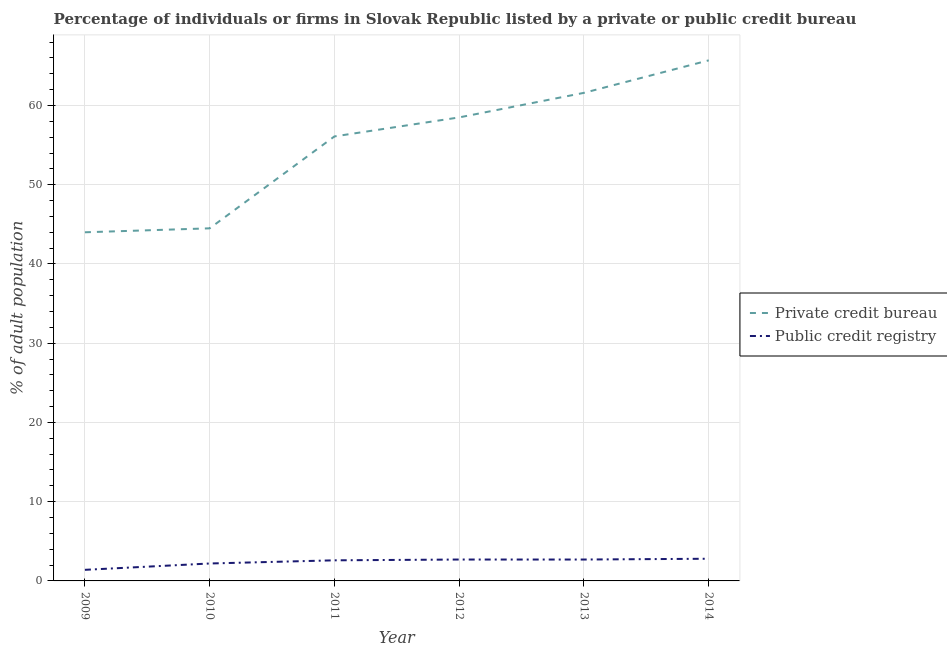How many different coloured lines are there?
Offer a terse response. 2. Is the number of lines equal to the number of legend labels?
Your answer should be compact. Yes. What is the percentage of firms listed by private credit bureau in 2014?
Your answer should be compact. 65.7. Across all years, what is the maximum percentage of firms listed by private credit bureau?
Offer a very short reply. 65.7. Across all years, what is the minimum percentage of firms listed by private credit bureau?
Make the answer very short. 44. In which year was the percentage of firms listed by public credit bureau maximum?
Offer a terse response. 2014. What is the total percentage of firms listed by private credit bureau in the graph?
Offer a very short reply. 330.4. What is the difference between the percentage of firms listed by private credit bureau in 2012 and that in 2013?
Offer a terse response. -3.1. What is the difference between the percentage of firms listed by public credit bureau in 2011 and the percentage of firms listed by private credit bureau in 2014?
Offer a very short reply. -63.1. What is the average percentage of firms listed by public credit bureau per year?
Provide a succinct answer. 2.4. In the year 2014, what is the difference between the percentage of firms listed by public credit bureau and percentage of firms listed by private credit bureau?
Provide a short and direct response. -62.9. What is the ratio of the percentage of firms listed by private credit bureau in 2011 to that in 2014?
Your answer should be very brief. 0.85. What is the difference between the highest and the second highest percentage of firms listed by private credit bureau?
Ensure brevity in your answer.  4.1. What is the difference between the highest and the lowest percentage of firms listed by private credit bureau?
Your response must be concise. 21.7. Is the sum of the percentage of firms listed by private credit bureau in 2011 and 2012 greater than the maximum percentage of firms listed by public credit bureau across all years?
Offer a very short reply. Yes. Is the percentage of firms listed by private credit bureau strictly greater than the percentage of firms listed by public credit bureau over the years?
Make the answer very short. Yes. How many years are there in the graph?
Make the answer very short. 6. What is the difference between two consecutive major ticks on the Y-axis?
Ensure brevity in your answer.  10. Are the values on the major ticks of Y-axis written in scientific E-notation?
Your answer should be very brief. No. Does the graph contain grids?
Offer a terse response. Yes. What is the title of the graph?
Offer a very short reply. Percentage of individuals or firms in Slovak Republic listed by a private or public credit bureau. Does "Automatic Teller Machines" appear as one of the legend labels in the graph?
Ensure brevity in your answer.  No. What is the label or title of the X-axis?
Provide a succinct answer. Year. What is the label or title of the Y-axis?
Provide a short and direct response. % of adult population. What is the % of adult population of Public credit registry in 2009?
Your answer should be very brief. 1.4. What is the % of adult population in Private credit bureau in 2010?
Your response must be concise. 44.5. What is the % of adult population of Private credit bureau in 2011?
Make the answer very short. 56.1. What is the % of adult population of Private credit bureau in 2012?
Your response must be concise. 58.5. What is the % of adult population in Private credit bureau in 2013?
Provide a succinct answer. 61.6. What is the % of adult population of Public credit registry in 2013?
Provide a short and direct response. 2.7. What is the % of adult population in Private credit bureau in 2014?
Make the answer very short. 65.7. Across all years, what is the maximum % of adult population of Private credit bureau?
Offer a terse response. 65.7. Across all years, what is the maximum % of adult population in Public credit registry?
Your answer should be compact. 2.8. What is the total % of adult population of Private credit bureau in the graph?
Your answer should be compact. 330.4. What is the total % of adult population in Public credit registry in the graph?
Make the answer very short. 14.4. What is the difference between the % of adult population in Private credit bureau in 2009 and that in 2010?
Your answer should be compact. -0.5. What is the difference between the % of adult population in Public credit registry in 2009 and that in 2010?
Provide a short and direct response. -0.8. What is the difference between the % of adult population of Private credit bureau in 2009 and that in 2011?
Make the answer very short. -12.1. What is the difference between the % of adult population of Private credit bureau in 2009 and that in 2012?
Make the answer very short. -14.5. What is the difference between the % of adult population in Private credit bureau in 2009 and that in 2013?
Your response must be concise. -17.6. What is the difference between the % of adult population of Private credit bureau in 2009 and that in 2014?
Give a very brief answer. -21.7. What is the difference between the % of adult population of Public credit registry in 2009 and that in 2014?
Your answer should be very brief. -1.4. What is the difference between the % of adult population of Private credit bureau in 2010 and that in 2011?
Your response must be concise. -11.6. What is the difference between the % of adult population in Private credit bureau in 2010 and that in 2012?
Your response must be concise. -14. What is the difference between the % of adult population in Public credit registry in 2010 and that in 2012?
Keep it short and to the point. -0.5. What is the difference between the % of adult population in Private credit bureau in 2010 and that in 2013?
Provide a succinct answer. -17.1. What is the difference between the % of adult population in Public credit registry in 2010 and that in 2013?
Provide a short and direct response. -0.5. What is the difference between the % of adult population of Private credit bureau in 2010 and that in 2014?
Offer a very short reply. -21.2. What is the difference between the % of adult population in Public credit registry in 2011 and that in 2012?
Provide a succinct answer. -0.1. What is the difference between the % of adult population of Private credit bureau in 2012 and that in 2013?
Provide a succinct answer. -3.1. What is the difference between the % of adult population in Public credit registry in 2012 and that in 2013?
Provide a short and direct response. 0. What is the difference between the % of adult population in Private credit bureau in 2012 and that in 2014?
Offer a terse response. -7.2. What is the difference between the % of adult population in Public credit registry in 2012 and that in 2014?
Offer a terse response. -0.1. What is the difference between the % of adult population of Private credit bureau in 2009 and the % of adult population of Public credit registry in 2010?
Provide a succinct answer. 41.8. What is the difference between the % of adult population of Private credit bureau in 2009 and the % of adult population of Public credit registry in 2011?
Give a very brief answer. 41.4. What is the difference between the % of adult population of Private credit bureau in 2009 and the % of adult population of Public credit registry in 2012?
Offer a terse response. 41.3. What is the difference between the % of adult population in Private credit bureau in 2009 and the % of adult population in Public credit registry in 2013?
Provide a short and direct response. 41.3. What is the difference between the % of adult population of Private credit bureau in 2009 and the % of adult population of Public credit registry in 2014?
Provide a short and direct response. 41.2. What is the difference between the % of adult population of Private credit bureau in 2010 and the % of adult population of Public credit registry in 2011?
Offer a terse response. 41.9. What is the difference between the % of adult population of Private credit bureau in 2010 and the % of adult population of Public credit registry in 2012?
Make the answer very short. 41.8. What is the difference between the % of adult population in Private credit bureau in 2010 and the % of adult population in Public credit registry in 2013?
Make the answer very short. 41.8. What is the difference between the % of adult population of Private credit bureau in 2010 and the % of adult population of Public credit registry in 2014?
Your answer should be very brief. 41.7. What is the difference between the % of adult population of Private credit bureau in 2011 and the % of adult population of Public credit registry in 2012?
Keep it short and to the point. 53.4. What is the difference between the % of adult population of Private credit bureau in 2011 and the % of adult population of Public credit registry in 2013?
Your answer should be compact. 53.4. What is the difference between the % of adult population of Private credit bureau in 2011 and the % of adult population of Public credit registry in 2014?
Provide a short and direct response. 53.3. What is the difference between the % of adult population in Private credit bureau in 2012 and the % of adult population in Public credit registry in 2013?
Provide a short and direct response. 55.8. What is the difference between the % of adult population of Private credit bureau in 2012 and the % of adult population of Public credit registry in 2014?
Keep it short and to the point. 55.7. What is the difference between the % of adult population of Private credit bureau in 2013 and the % of adult population of Public credit registry in 2014?
Provide a short and direct response. 58.8. What is the average % of adult population of Private credit bureau per year?
Your answer should be compact. 55.07. What is the average % of adult population of Public credit registry per year?
Ensure brevity in your answer.  2.4. In the year 2009, what is the difference between the % of adult population of Private credit bureau and % of adult population of Public credit registry?
Offer a terse response. 42.6. In the year 2010, what is the difference between the % of adult population in Private credit bureau and % of adult population in Public credit registry?
Provide a short and direct response. 42.3. In the year 2011, what is the difference between the % of adult population of Private credit bureau and % of adult population of Public credit registry?
Your answer should be very brief. 53.5. In the year 2012, what is the difference between the % of adult population in Private credit bureau and % of adult population in Public credit registry?
Provide a succinct answer. 55.8. In the year 2013, what is the difference between the % of adult population in Private credit bureau and % of adult population in Public credit registry?
Your response must be concise. 58.9. In the year 2014, what is the difference between the % of adult population in Private credit bureau and % of adult population in Public credit registry?
Make the answer very short. 62.9. What is the ratio of the % of adult population of Public credit registry in 2009 to that in 2010?
Provide a succinct answer. 0.64. What is the ratio of the % of adult population in Private credit bureau in 2009 to that in 2011?
Your answer should be compact. 0.78. What is the ratio of the % of adult population in Public credit registry in 2009 to that in 2011?
Make the answer very short. 0.54. What is the ratio of the % of adult population of Private credit bureau in 2009 to that in 2012?
Offer a very short reply. 0.75. What is the ratio of the % of adult population in Public credit registry in 2009 to that in 2012?
Your answer should be very brief. 0.52. What is the ratio of the % of adult population in Public credit registry in 2009 to that in 2013?
Your answer should be very brief. 0.52. What is the ratio of the % of adult population of Private credit bureau in 2009 to that in 2014?
Make the answer very short. 0.67. What is the ratio of the % of adult population in Private credit bureau in 2010 to that in 2011?
Offer a very short reply. 0.79. What is the ratio of the % of adult population of Public credit registry in 2010 to that in 2011?
Your answer should be compact. 0.85. What is the ratio of the % of adult population in Private credit bureau in 2010 to that in 2012?
Your response must be concise. 0.76. What is the ratio of the % of adult population of Public credit registry in 2010 to that in 2012?
Give a very brief answer. 0.81. What is the ratio of the % of adult population in Private credit bureau in 2010 to that in 2013?
Your answer should be very brief. 0.72. What is the ratio of the % of adult population in Public credit registry in 2010 to that in 2013?
Provide a short and direct response. 0.81. What is the ratio of the % of adult population of Private credit bureau in 2010 to that in 2014?
Keep it short and to the point. 0.68. What is the ratio of the % of adult population of Public credit registry in 2010 to that in 2014?
Make the answer very short. 0.79. What is the ratio of the % of adult population in Private credit bureau in 2011 to that in 2012?
Provide a short and direct response. 0.96. What is the ratio of the % of adult population of Private credit bureau in 2011 to that in 2013?
Provide a succinct answer. 0.91. What is the ratio of the % of adult population of Public credit registry in 2011 to that in 2013?
Your answer should be compact. 0.96. What is the ratio of the % of adult population of Private credit bureau in 2011 to that in 2014?
Provide a short and direct response. 0.85. What is the ratio of the % of adult population of Private credit bureau in 2012 to that in 2013?
Keep it short and to the point. 0.95. What is the ratio of the % of adult population in Public credit registry in 2012 to that in 2013?
Give a very brief answer. 1. What is the ratio of the % of adult population in Private credit bureau in 2012 to that in 2014?
Provide a succinct answer. 0.89. What is the ratio of the % of adult population in Public credit registry in 2012 to that in 2014?
Offer a terse response. 0.96. What is the ratio of the % of adult population of Private credit bureau in 2013 to that in 2014?
Offer a very short reply. 0.94. What is the difference between the highest and the second highest % of adult population of Private credit bureau?
Your response must be concise. 4.1. What is the difference between the highest and the second highest % of adult population in Public credit registry?
Ensure brevity in your answer.  0.1. What is the difference between the highest and the lowest % of adult population of Private credit bureau?
Your response must be concise. 21.7. What is the difference between the highest and the lowest % of adult population in Public credit registry?
Your response must be concise. 1.4. 